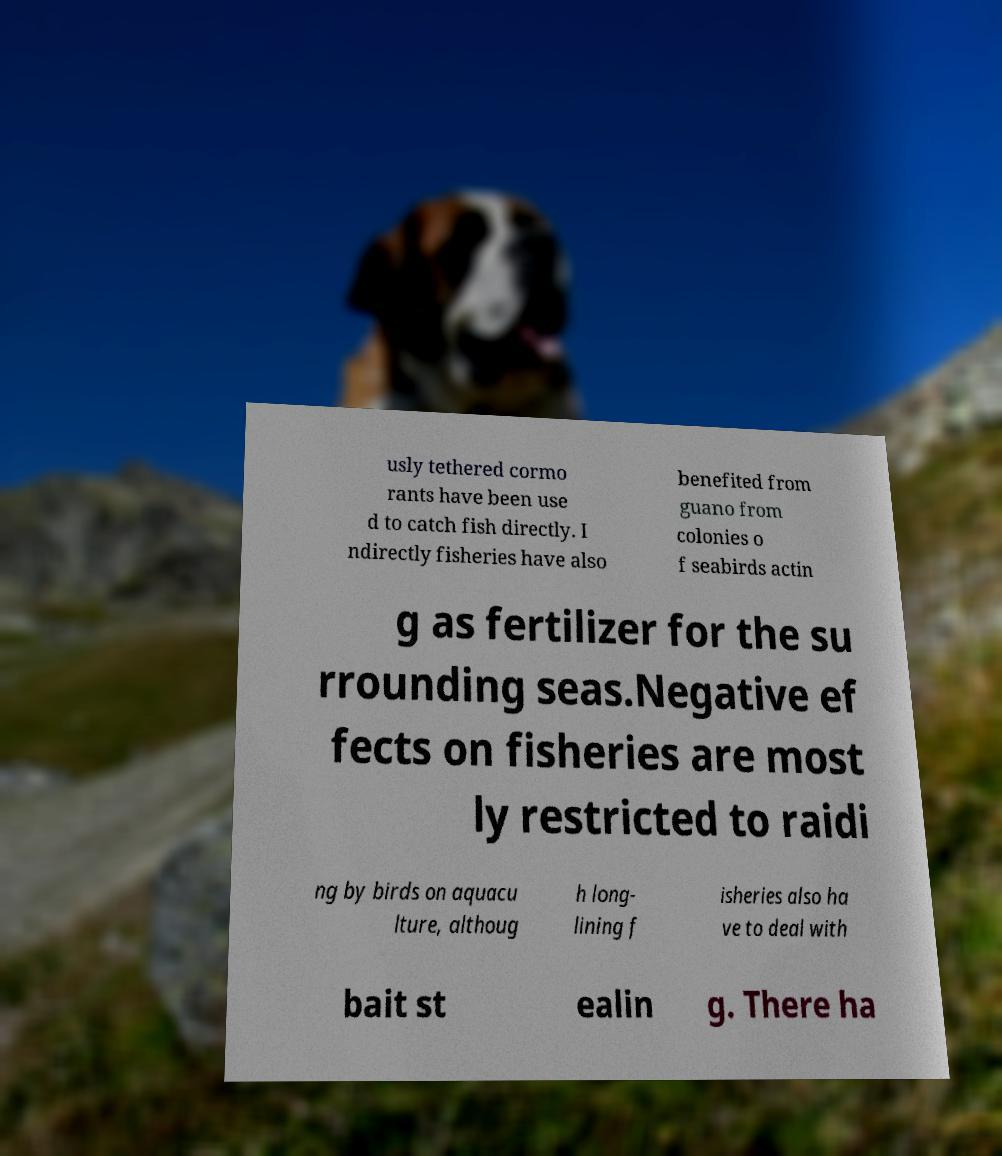Can you read and provide the text displayed in the image?This photo seems to have some interesting text. Can you extract and type it out for me? usly tethered cormo rants have been use d to catch fish directly. I ndirectly fisheries have also benefited from guano from colonies o f seabirds actin g as fertilizer for the su rrounding seas.Negative ef fects on fisheries are most ly restricted to raidi ng by birds on aquacu lture, althoug h long- lining f isheries also ha ve to deal with bait st ealin g. There ha 